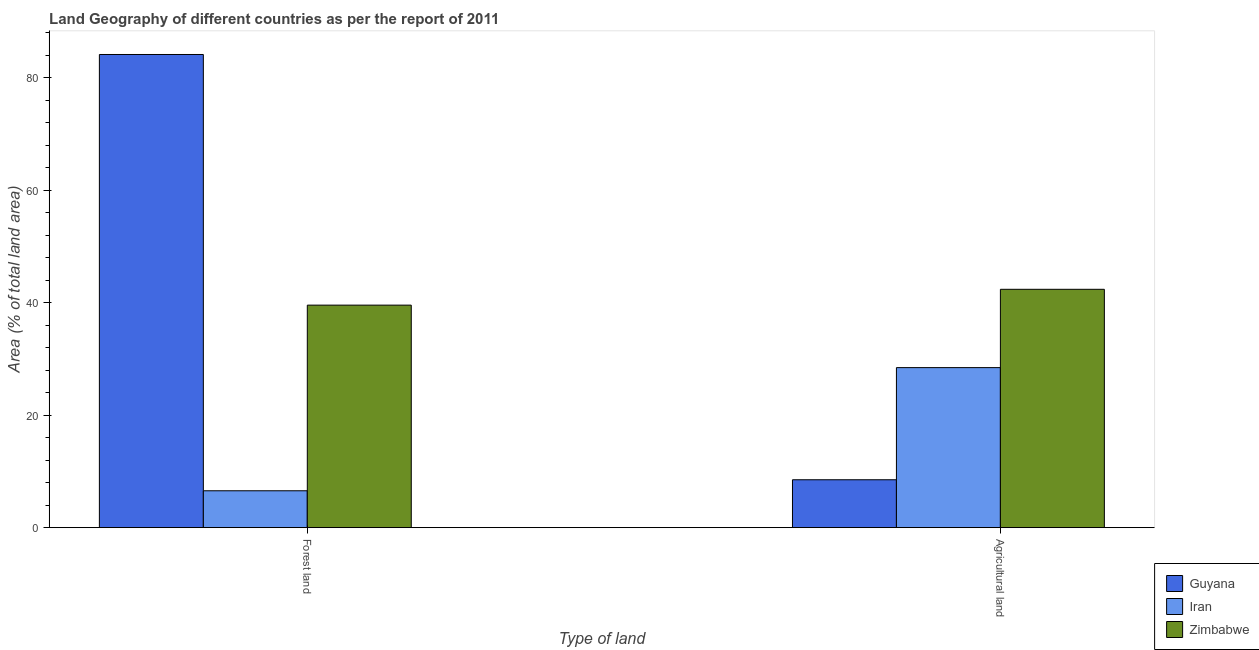Are the number of bars per tick equal to the number of legend labels?
Offer a terse response. Yes. How many bars are there on the 1st tick from the left?
Your response must be concise. 3. How many bars are there on the 2nd tick from the right?
Ensure brevity in your answer.  3. What is the label of the 1st group of bars from the left?
Offer a terse response. Forest land. What is the percentage of land area under forests in Iran?
Keep it short and to the point. 6.57. Across all countries, what is the maximum percentage of land area under forests?
Your answer should be very brief. 84.16. Across all countries, what is the minimum percentage of land area under agriculture?
Give a very brief answer. 8.52. In which country was the percentage of land area under forests maximum?
Provide a short and direct response. Guyana. In which country was the percentage of land area under forests minimum?
Ensure brevity in your answer.  Iran. What is the total percentage of land area under agriculture in the graph?
Keep it short and to the point. 79.38. What is the difference between the percentage of land area under agriculture in Zimbabwe and that in Iran?
Your answer should be compact. 13.93. What is the difference between the percentage of land area under forests in Guyana and the percentage of land area under agriculture in Iran?
Provide a short and direct response. 55.69. What is the average percentage of land area under forests per country?
Provide a short and direct response. 43.43. What is the difference between the percentage of land area under agriculture and percentage of land area under forests in Iran?
Offer a terse response. 21.9. In how many countries, is the percentage of land area under forests greater than 84 %?
Offer a terse response. 1. What is the ratio of the percentage of land area under agriculture in Zimbabwe to that in Iran?
Your answer should be compact. 1.49. Is the percentage of land area under agriculture in Guyana less than that in Zimbabwe?
Offer a terse response. Yes. What does the 3rd bar from the left in Forest land represents?
Your answer should be very brief. Zimbabwe. What does the 3rd bar from the right in Forest land represents?
Your response must be concise. Guyana. How many countries are there in the graph?
Make the answer very short. 3. Are the values on the major ticks of Y-axis written in scientific E-notation?
Ensure brevity in your answer.  No. Does the graph contain grids?
Give a very brief answer. No. How are the legend labels stacked?
Your response must be concise. Vertical. What is the title of the graph?
Give a very brief answer. Land Geography of different countries as per the report of 2011. What is the label or title of the X-axis?
Offer a very short reply. Type of land. What is the label or title of the Y-axis?
Keep it short and to the point. Area (% of total land area). What is the Area (% of total land area) in Guyana in Forest land?
Your answer should be compact. 84.16. What is the Area (% of total land area) of Iran in Forest land?
Your response must be concise. 6.57. What is the Area (% of total land area) of Zimbabwe in Forest land?
Your response must be concise. 39.58. What is the Area (% of total land area) in Guyana in Agricultural land?
Provide a short and direct response. 8.52. What is the Area (% of total land area) of Iran in Agricultural land?
Provide a short and direct response. 28.47. What is the Area (% of total land area) in Zimbabwe in Agricultural land?
Offer a very short reply. 42.39. Across all Type of land, what is the maximum Area (% of total land area) of Guyana?
Make the answer very short. 84.16. Across all Type of land, what is the maximum Area (% of total land area) in Iran?
Keep it short and to the point. 28.47. Across all Type of land, what is the maximum Area (% of total land area) in Zimbabwe?
Provide a short and direct response. 42.39. Across all Type of land, what is the minimum Area (% of total land area) of Guyana?
Ensure brevity in your answer.  8.52. Across all Type of land, what is the minimum Area (% of total land area) in Iran?
Provide a short and direct response. 6.57. Across all Type of land, what is the minimum Area (% of total land area) of Zimbabwe?
Keep it short and to the point. 39.58. What is the total Area (% of total land area) in Guyana in the graph?
Your response must be concise. 92.68. What is the total Area (% of total land area) of Iran in the graph?
Provide a short and direct response. 35.03. What is the total Area (% of total land area) in Zimbabwe in the graph?
Offer a very short reply. 81.97. What is the difference between the Area (% of total land area) of Guyana in Forest land and that in Agricultural land?
Ensure brevity in your answer.  75.63. What is the difference between the Area (% of total land area) in Iran in Forest land and that in Agricultural land?
Provide a short and direct response. -21.9. What is the difference between the Area (% of total land area) in Zimbabwe in Forest land and that in Agricultural land?
Your response must be concise. -2.81. What is the difference between the Area (% of total land area) in Guyana in Forest land and the Area (% of total land area) in Iran in Agricultural land?
Your answer should be compact. 55.69. What is the difference between the Area (% of total land area) of Guyana in Forest land and the Area (% of total land area) of Zimbabwe in Agricultural land?
Provide a succinct answer. 41.76. What is the difference between the Area (% of total land area) in Iran in Forest land and the Area (% of total land area) in Zimbabwe in Agricultural land?
Your response must be concise. -35.83. What is the average Area (% of total land area) of Guyana per Type of land?
Provide a short and direct response. 46.34. What is the average Area (% of total land area) of Iran per Type of land?
Offer a very short reply. 17.52. What is the average Area (% of total land area) in Zimbabwe per Type of land?
Provide a succinct answer. 40.99. What is the difference between the Area (% of total land area) in Guyana and Area (% of total land area) in Iran in Forest land?
Offer a very short reply. 77.59. What is the difference between the Area (% of total land area) of Guyana and Area (% of total land area) of Zimbabwe in Forest land?
Provide a succinct answer. 44.58. What is the difference between the Area (% of total land area) in Iran and Area (% of total land area) in Zimbabwe in Forest land?
Your answer should be compact. -33.01. What is the difference between the Area (% of total land area) in Guyana and Area (% of total land area) in Iran in Agricultural land?
Provide a succinct answer. -19.94. What is the difference between the Area (% of total land area) in Guyana and Area (% of total land area) in Zimbabwe in Agricultural land?
Your response must be concise. -33.87. What is the difference between the Area (% of total land area) in Iran and Area (% of total land area) in Zimbabwe in Agricultural land?
Your answer should be compact. -13.93. What is the ratio of the Area (% of total land area) in Guyana in Forest land to that in Agricultural land?
Your answer should be very brief. 9.87. What is the ratio of the Area (% of total land area) of Iran in Forest land to that in Agricultural land?
Give a very brief answer. 0.23. What is the ratio of the Area (% of total land area) in Zimbabwe in Forest land to that in Agricultural land?
Make the answer very short. 0.93. What is the difference between the highest and the second highest Area (% of total land area) in Guyana?
Your answer should be very brief. 75.63. What is the difference between the highest and the second highest Area (% of total land area) of Iran?
Your answer should be very brief. 21.9. What is the difference between the highest and the second highest Area (% of total land area) of Zimbabwe?
Your response must be concise. 2.81. What is the difference between the highest and the lowest Area (% of total land area) of Guyana?
Your answer should be compact. 75.63. What is the difference between the highest and the lowest Area (% of total land area) in Iran?
Give a very brief answer. 21.9. What is the difference between the highest and the lowest Area (% of total land area) in Zimbabwe?
Make the answer very short. 2.81. 